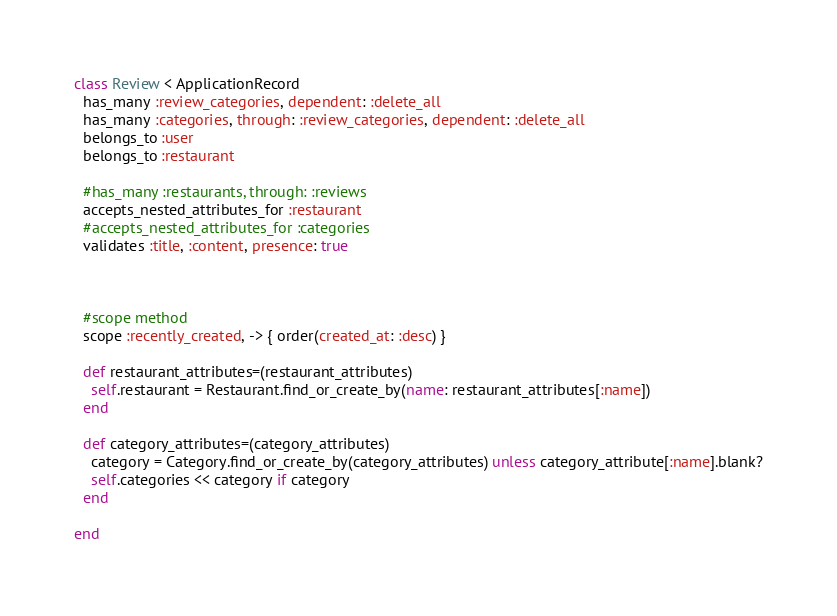Convert code to text. <code><loc_0><loc_0><loc_500><loc_500><_Ruby_>class Review < ApplicationRecord
  has_many :review_categories, dependent: :delete_all
  has_many :categories, through: :review_categories, dependent: :delete_all
  belongs_to :user
  belongs_to :restaurant
  
  #has_many :restaurants, through: :reviews
  accepts_nested_attributes_for :restaurant
  #accepts_nested_attributes_for :categories
  validates :title, :content, presence: true
  


  #scope method
  scope :recently_created, -> { order(created_at: :desc) }
    
  def restaurant_attributes=(restaurant_attributes)
    self.restaurant = Restaurant.find_or_create_by(name: restaurant_attributes[:name])
  end

  def category_attributes=(category_attributes)
    category = Category.find_or_create_by(category_attributes) unless category_attribute[:name].blank?
    self.categories << category if category
  end

end</code> 